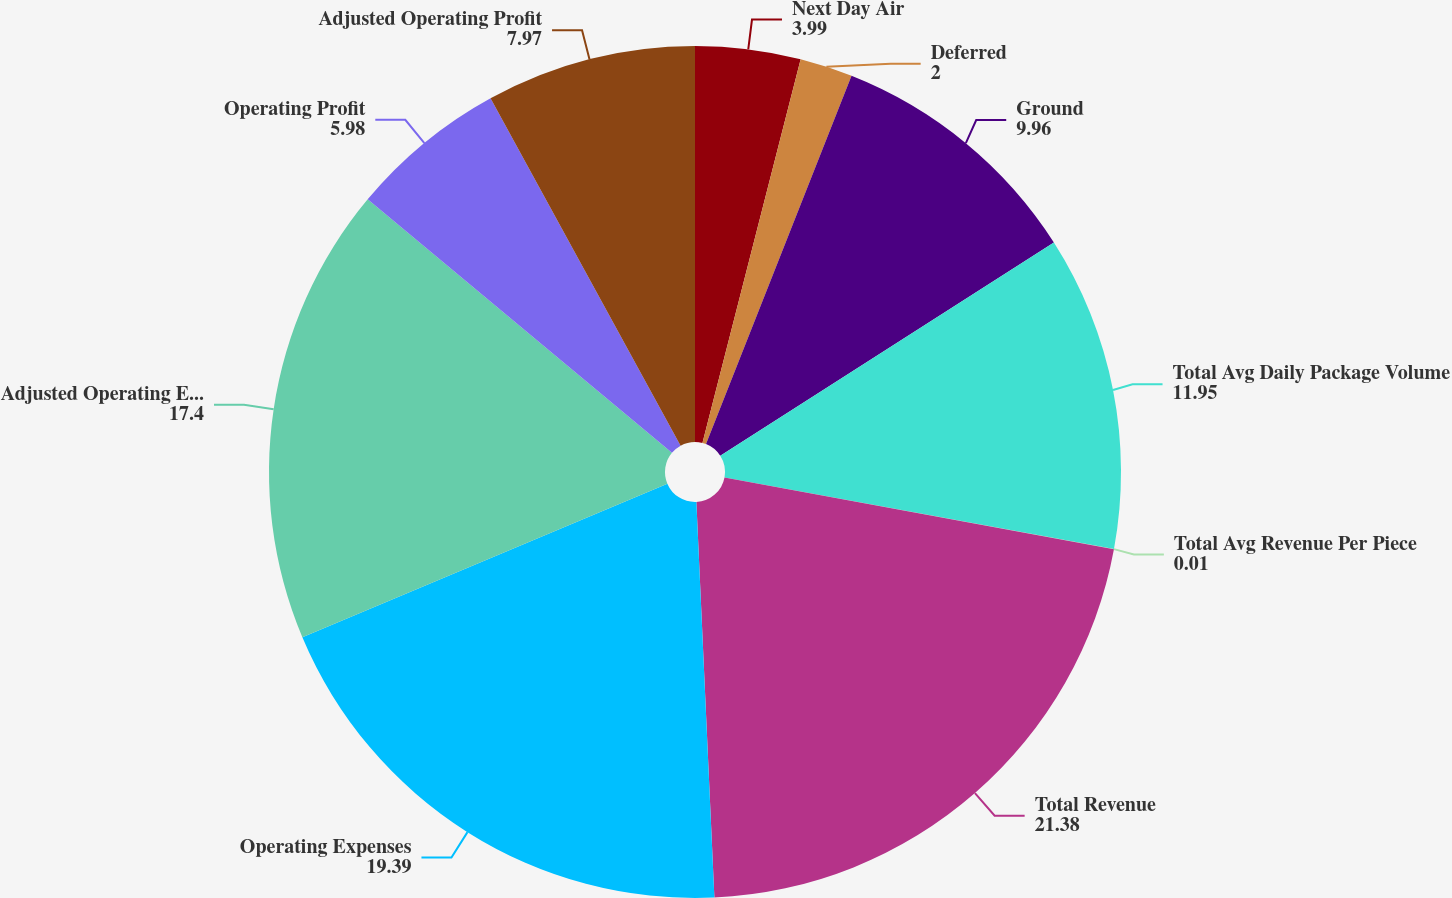Convert chart to OTSL. <chart><loc_0><loc_0><loc_500><loc_500><pie_chart><fcel>Next Day Air<fcel>Deferred<fcel>Ground<fcel>Total Avg Daily Package Volume<fcel>Total Avg Revenue Per Piece<fcel>Total Revenue<fcel>Operating Expenses<fcel>Adjusted Operating Expenses<fcel>Operating Profit<fcel>Adjusted Operating Profit<nl><fcel>3.99%<fcel>2.0%<fcel>9.96%<fcel>11.95%<fcel>0.01%<fcel>21.38%<fcel>19.39%<fcel>17.4%<fcel>5.98%<fcel>7.97%<nl></chart> 